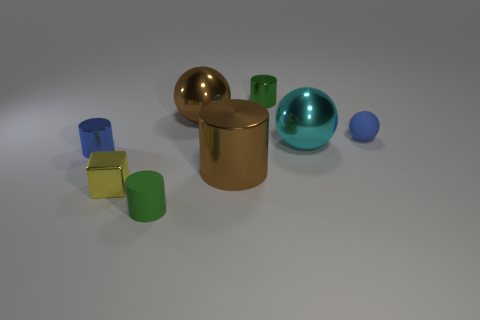Add 1 tiny metal cylinders. How many objects exist? 9 Subtract all cubes. How many objects are left? 7 Subtract 1 blue balls. How many objects are left? 7 Subtract all tiny yellow metal blocks. Subtract all cylinders. How many objects are left? 3 Add 5 blue spheres. How many blue spheres are left? 6 Add 8 brown metallic objects. How many brown metallic objects exist? 10 